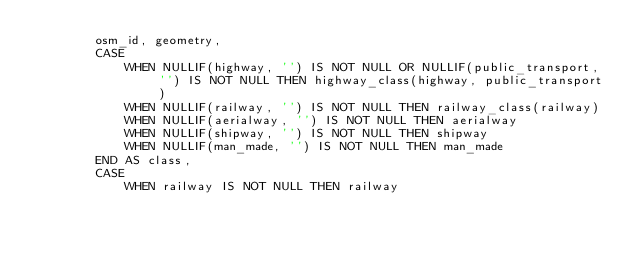<code> <loc_0><loc_0><loc_500><loc_500><_SQL_>        osm_id, geometry,
        CASE
            WHEN NULLIF(highway, '') IS NOT NULL OR NULLIF(public_transport, '') IS NOT NULL THEN highway_class(highway, public_transport)
            WHEN NULLIF(railway, '') IS NOT NULL THEN railway_class(railway)
            WHEN NULLIF(aerialway, '') IS NOT NULL THEN aerialway
            WHEN NULLIF(shipway, '') IS NOT NULL THEN shipway
            WHEN NULLIF(man_made, '') IS NOT NULL THEN man_made
        END AS class,
        CASE
            WHEN railway IS NOT NULL THEN railway</code> 